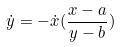Convert formula to latex. <formula><loc_0><loc_0><loc_500><loc_500>\dot { y } = - \dot { x } ( \frac { x - a } { y - b } )</formula> 